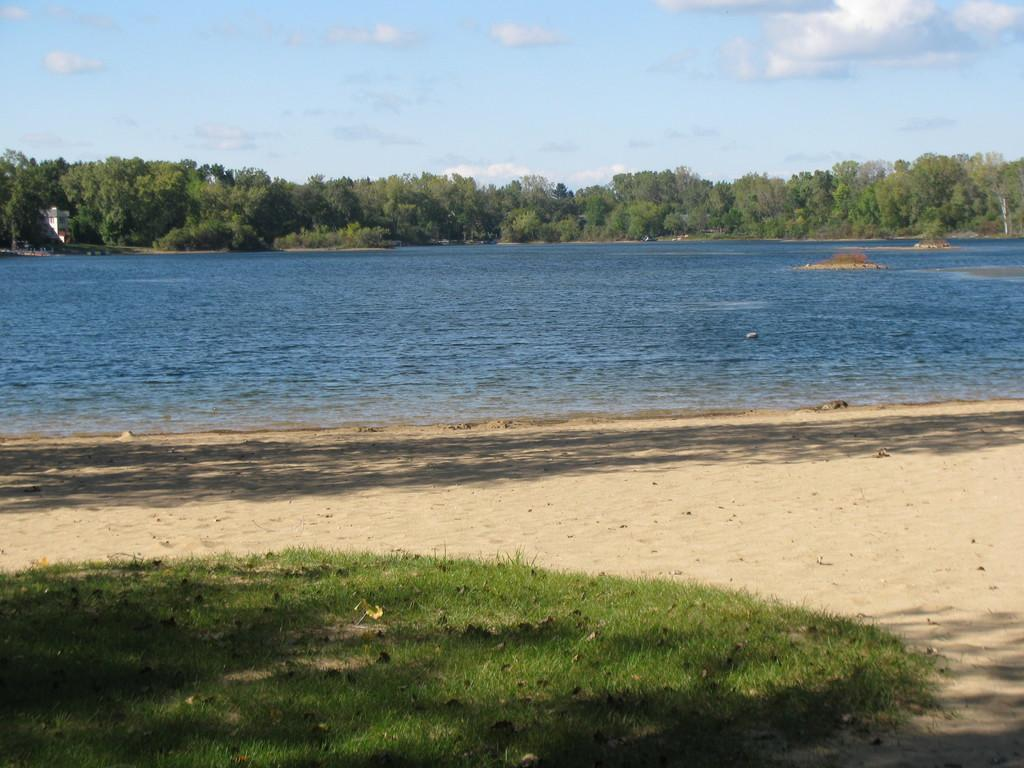What type of terrain is visible in the image? There is sand and grass visible in the image. What can be seen in the background of the image? There is water and a cloudy sky visible in the background of the image. How does the turkey blow the pen in the image? There is no turkey or pen present in the image. 